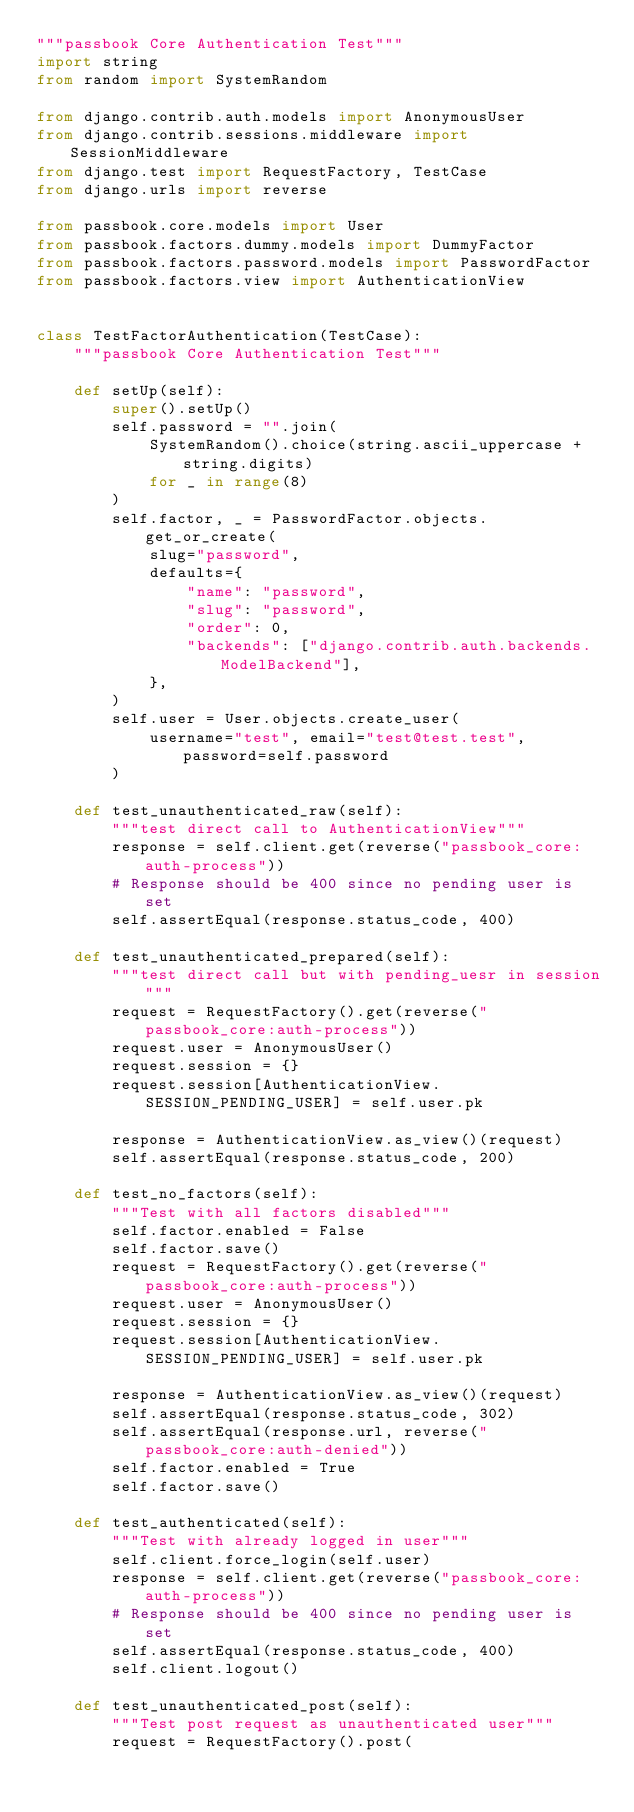<code> <loc_0><loc_0><loc_500><loc_500><_Python_>"""passbook Core Authentication Test"""
import string
from random import SystemRandom

from django.contrib.auth.models import AnonymousUser
from django.contrib.sessions.middleware import SessionMiddleware
from django.test import RequestFactory, TestCase
from django.urls import reverse

from passbook.core.models import User
from passbook.factors.dummy.models import DummyFactor
from passbook.factors.password.models import PasswordFactor
from passbook.factors.view import AuthenticationView


class TestFactorAuthentication(TestCase):
    """passbook Core Authentication Test"""

    def setUp(self):
        super().setUp()
        self.password = "".join(
            SystemRandom().choice(string.ascii_uppercase + string.digits)
            for _ in range(8)
        )
        self.factor, _ = PasswordFactor.objects.get_or_create(
            slug="password",
            defaults={
                "name": "password",
                "slug": "password",
                "order": 0,
                "backends": ["django.contrib.auth.backends.ModelBackend"],
            },
        )
        self.user = User.objects.create_user(
            username="test", email="test@test.test", password=self.password
        )

    def test_unauthenticated_raw(self):
        """test direct call to AuthenticationView"""
        response = self.client.get(reverse("passbook_core:auth-process"))
        # Response should be 400 since no pending user is set
        self.assertEqual(response.status_code, 400)

    def test_unauthenticated_prepared(self):
        """test direct call but with pending_uesr in session"""
        request = RequestFactory().get(reverse("passbook_core:auth-process"))
        request.user = AnonymousUser()
        request.session = {}
        request.session[AuthenticationView.SESSION_PENDING_USER] = self.user.pk

        response = AuthenticationView.as_view()(request)
        self.assertEqual(response.status_code, 200)

    def test_no_factors(self):
        """Test with all factors disabled"""
        self.factor.enabled = False
        self.factor.save()
        request = RequestFactory().get(reverse("passbook_core:auth-process"))
        request.user = AnonymousUser()
        request.session = {}
        request.session[AuthenticationView.SESSION_PENDING_USER] = self.user.pk

        response = AuthenticationView.as_view()(request)
        self.assertEqual(response.status_code, 302)
        self.assertEqual(response.url, reverse("passbook_core:auth-denied"))
        self.factor.enabled = True
        self.factor.save()

    def test_authenticated(self):
        """Test with already logged in user"""
        self.client.force_login(self.user)
        response = self.client.get(reverse("passbook_core:auth-process"))
        # Response should be 400 since no pending user is set
        self.assertEqual(response.status_code, 400)
        self.client.logout()

    def test_unauthenticated_post(self):
        """Test post request as unauthenticated user"""
        request = RequestFactory().post(</code> 